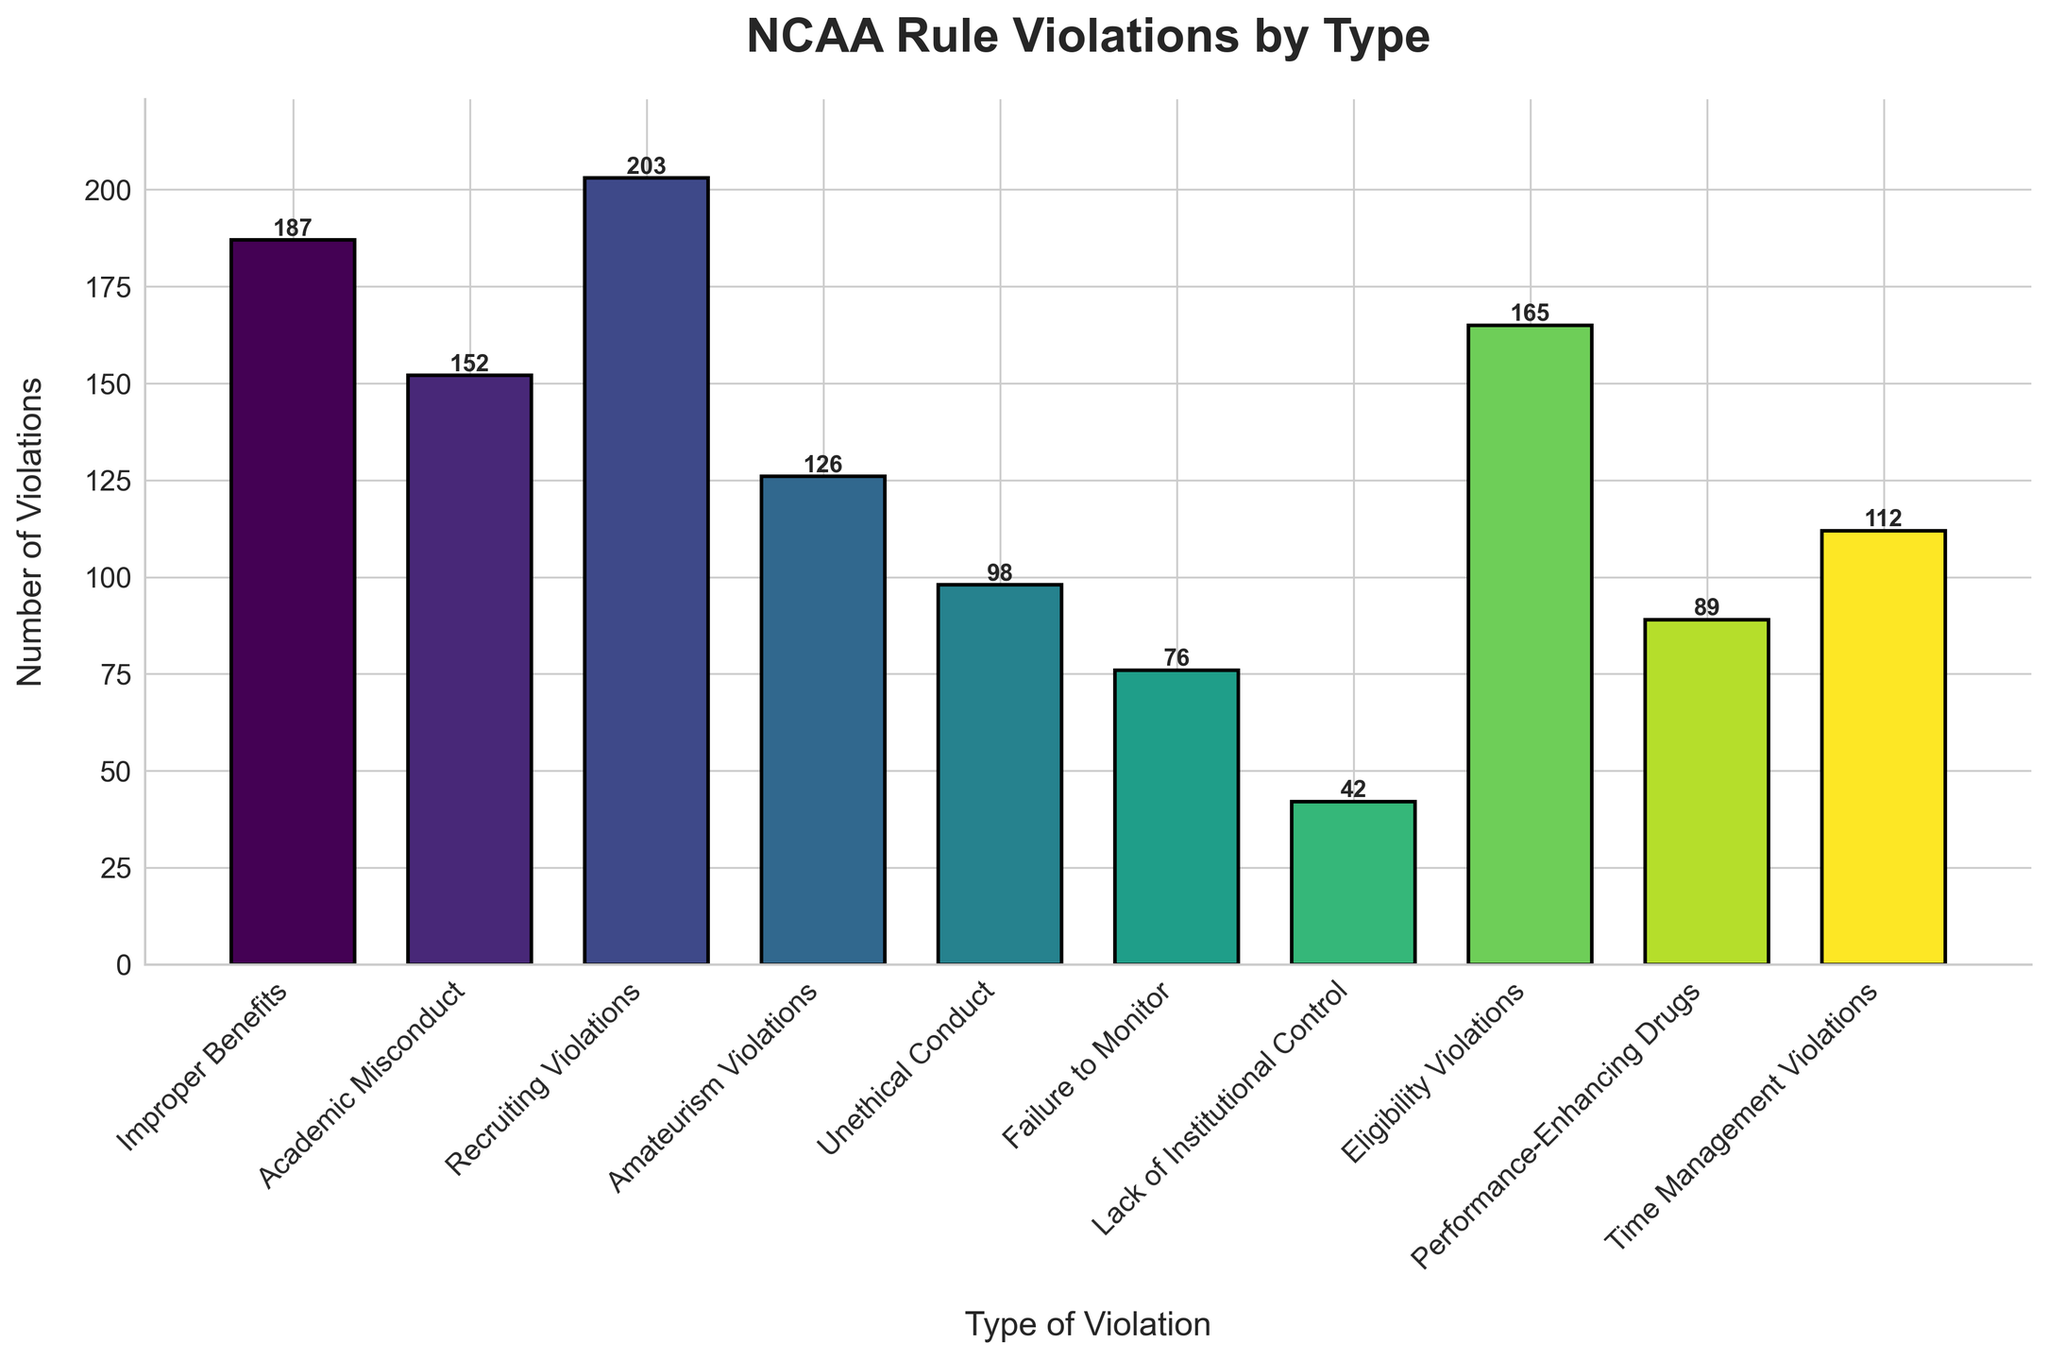What type of violation has the highest number of violations? The tallest bar represents the type of violation with the highest number of violations. In this chart, "Recruiting Violations" is the highest with 203 violations.
Answer: Recruiting Violations How many more "Improper Benefits" violations are there compared to "Unethical Conduct" violations? To find the difference, subtract the number of "Unethical Conduct" violations from the "Improper Benefits" violations (187 - 98).
Answer: 89 What is the total number of violations for "Academic Misconduct" and "Eligibility Violations" combined? Add the numbers for "Academic Misconduct" and "Eligibility Violations" (152 + 165).
Answer: 317 Which type of violation has fewer occurrences, "Performance-Enhancing Drugs" or "Time Management Violations"? Compare the heights of the bars for "Performance-Enhancing Drugs" (89) and "Time Management Violations" (112). "Performance-Enhancing Drugs" has fewer violations.
Answer: Performance-Enhancing Drugs What is the sum of violations for "Lack of Institutional Control," "Failure to Monitor," and "Unethical Conduct"? Add the number of violations for each type: "Lack of Institutional Control" (42), "Failure to Monitor" (76), and "Unethical Conduct" (98).
Answer: 216 What is the average number of violations in the dataset? Sum all the violations and divide by the number of types (187 + 152 + 203 + 126 + 98 + 76 + 42 + 165 + 89 + 112) / 10. The total sum is 1,250; dividing by 10 gives the average.
Answer: 125 Which violation types have fewer than 100 occurrences? Look for bars shorter than 100. The types are "Failure to Monitor" (76) and "Lack of Institutional Control" (42).
Answer: Failure to Monitor, Lack of Institutional Control What percentage of total violations does "Recruiting Violations" represent? Divide the number of "Recruiting Violations" by the total number of violations and multiply by 100. (203 / 1250) * 100 = 16.24%.
Answer: 16.24% How many more "Eligibility Violations" are there than "Amateurism Violations"? Subtract the number of "Amateurism Violations" from "Eligibility Violations" (165 - 126).
Answer: 39 Which type of violation has the second-highest number of occurrences? Identify the second tallest bar. "Improper Benefits" is next after "Recruiting Violations" with 187 violations.
Answer: Improper Benefits 